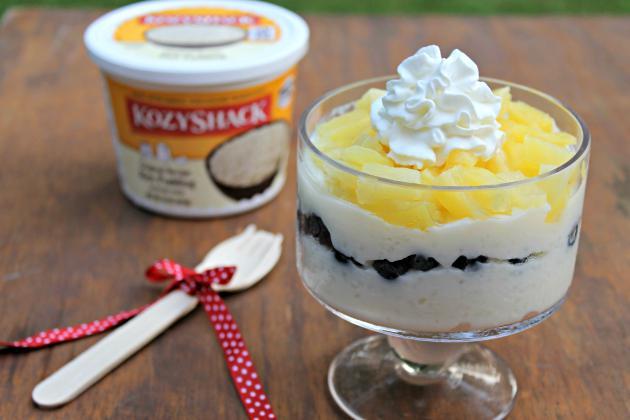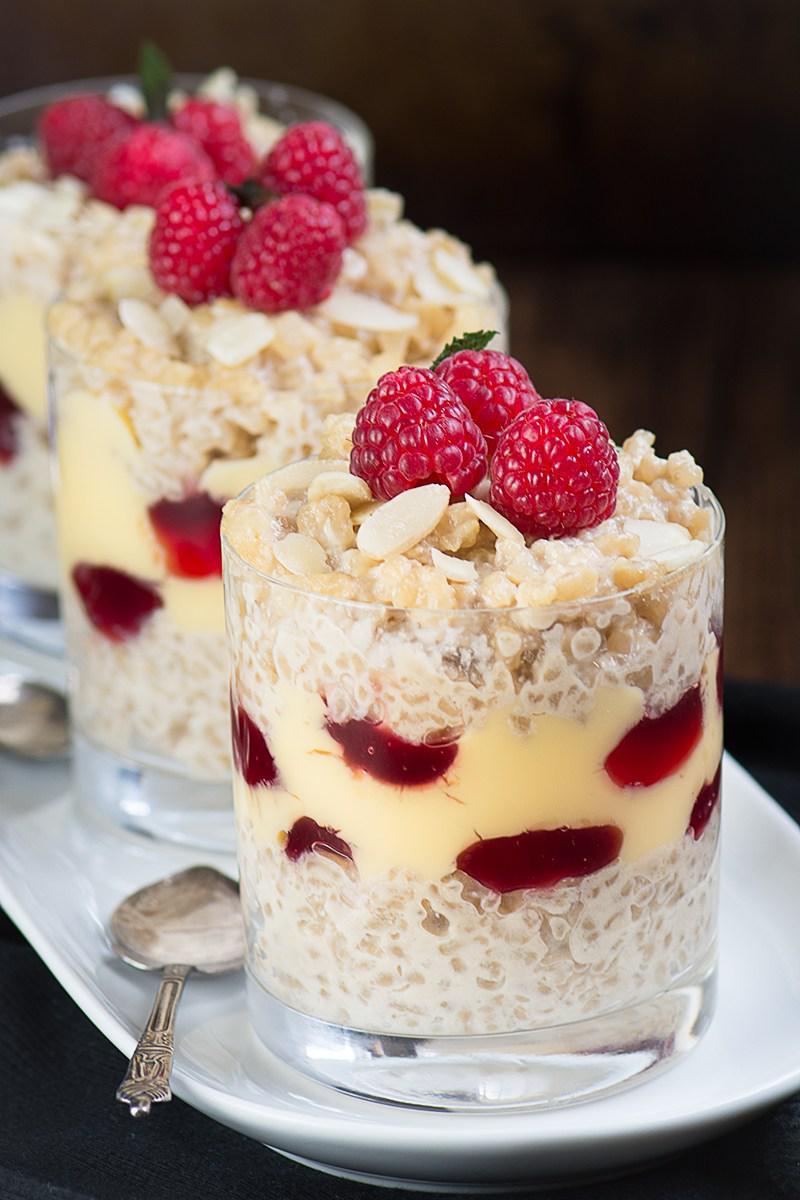The first image is the image on the left, the second image is the image on the right. Examine the images to the left and right. Is the description "There is white flatware with a ribbon tied around it." accurate? Answer yes or no. Yes. 